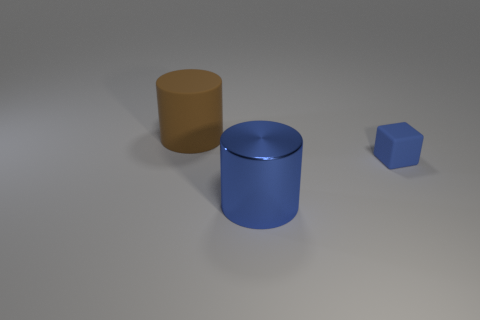Add 1 small blue matte cubes. How many objects exist? 4 Subtract all blocks. How many objects are left? 2 Add 2 brown rubber things. How many brown rubber things exist? 3 Subtract 1 blue cubes. How many objects are left? 2 Subtract all big brown rubber cylinders. Subtract all big yellow metallic balls. How many objects are left? 2 Add 2 cylinders. How many cylinders are left? 4 